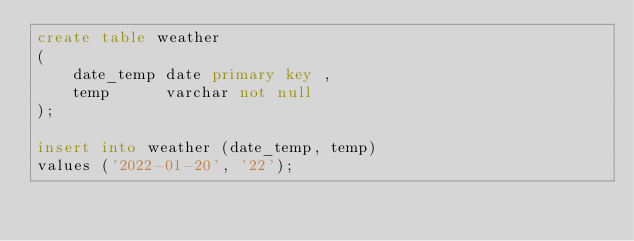Convert code to text. <code><loc_0><loc_0><loc_500><loc_500><_SQL_>create table weather
(
    date_temp date primary key ,
    temp      varchar not null
);

insert into weather (date_temp, temp)
values ('2022-01-20', '22');</code> 